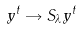Convert formula to latex. <formula><loc_0><loc_0><loc_500><loc_500>y ^ { t } \rightarrow S _ { \lambda } y ^ { t }</formula> 